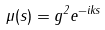Convert formula to latex. <formula><loc_0><loc_0><loc_500><loc_500>\mu ( s ) = g ^ { 2 } e ^ { - i k s }</formula> 